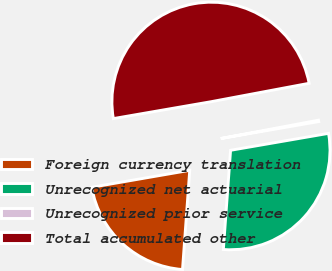Convert chart to OTSL. <chart><loc_0><loc_0><loc_500><loc_500><pie_chart><fcel>Foreign currency translation<fcel>Unrecognized net actuarial<fcel>Unrecognized prior service<fcel>Total accumulated other<nl><fcel>21.12%<fcel>28.88%<fcel>0.23%<fcel>49.77%<nl></chart> 